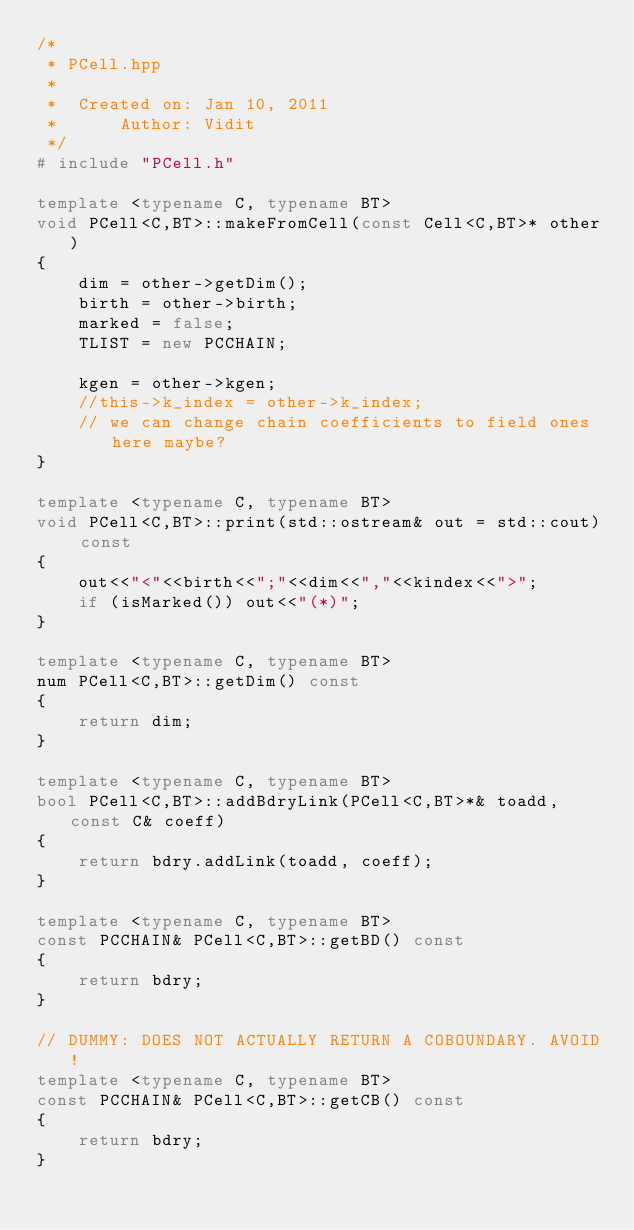<code> <loc_0><loc_0><loc_500><loc_500><_C++_>/*
 * PCell.hpp
 *
 *  Created on: Jan 10, 2011
 *      Author: Vidit
 */
# include "PCell.h"

template <typename C, typename BT>
void PCell<C,BT>::makeFromCell(const Cell<C,BT>* other)
{
	dim = other->getDim();
	birth = other->birth;
	marked = false;
	TLIST = new PCCHAIN;

	kgen = other->kgen;
	//this->k_index = other->k_index;
	// we can change chain coefficients to field ones here maybe?
}

template <typename C, typename BT>
void PCell<C,BT>::print(std::ostream& out = std::cout) const
{
	out<<"<"<<birth<<";"<<dim<<","<<kindex<<">";
	if (isMarked()) out<<"(*)";
}

template <typename C, typename BT>
num PCell<C,BT>::getDim() const
{
	return dim;
}

template <typename C, typename BT>
bool PCell<C,BT>::addBdryLink(PCell<C,BT>*& toadd, const C& coeff)
{
	return bdry.addLink(toadd, coeff);
}

template <typename C, typename BT>
const PCCHAIN& PCell<C,BT>::getBD() const
{
	return bdry;
}

// DUMMY: DOES NOT ACTUALLY RETURN A COBOUNDARY. AVOID!
template <typename C, typename BT>
const PCCHAIN& PCell<C,BT>::getCB() const
{
	return bdry;
}</code> 